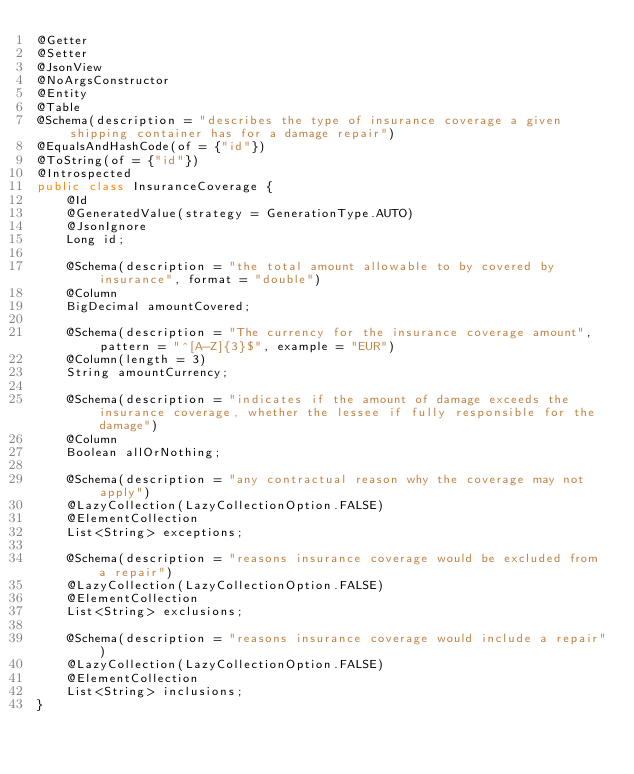Convert code to text. <code><loc_0><loc_0><loc_500><loc_500><_Java_>@Getter
@Setter
@JsonView
@NoArgsConstructor
@Entity
@Table
@Schema(description = "describes the type of insurance coverage a given shipping container has for a damage repair")
@EqualsAndHashCode(of = {"id"})
@ToString(of = {"id"})
@Introspected
public class InsuranceCoverage {
    @Id
    @GeneratedValue(strategy = GenerationType.AUTO)
    @JsonIgnore
    Long id;

    @Schema(description = "the total amount allowable to by covered by insurance", format = "double")
    @Column
    BigDecimal amountCovered;

    @Schema(description = "The currency for the insurance coverage amount", pattern = "^[A-Z]{3}$", example = "EUR")
    @Column(length = 3)
    String amountCurrency;

    @Schema(description = "indicates if the amount of damage exceeds the insurance coverage, whether the lessee if fully responsible for the damage")
    @Column
    Boolean allOrNothing;

    @Schema(description = "any contractual reason why the coverage may not apply")
    @LazyCollection(LazyCollectionOption.FALSE)
    @ElementCollection
    List<String> exceptions;

    @Schema(description = "reasons insurance coverage would be excluded from a repair")
    @LazyCollection(LazyCollectionOption.FALSE)
    @ElementCollection
    List<String> exclusions;

    @Schema(description = "reasons insurance coverage would include a repair")
    @LazyCollection(LazyCollectionOption.FALSE)
    @ElementCollection
    List<String> inclusions;
}
</code> 